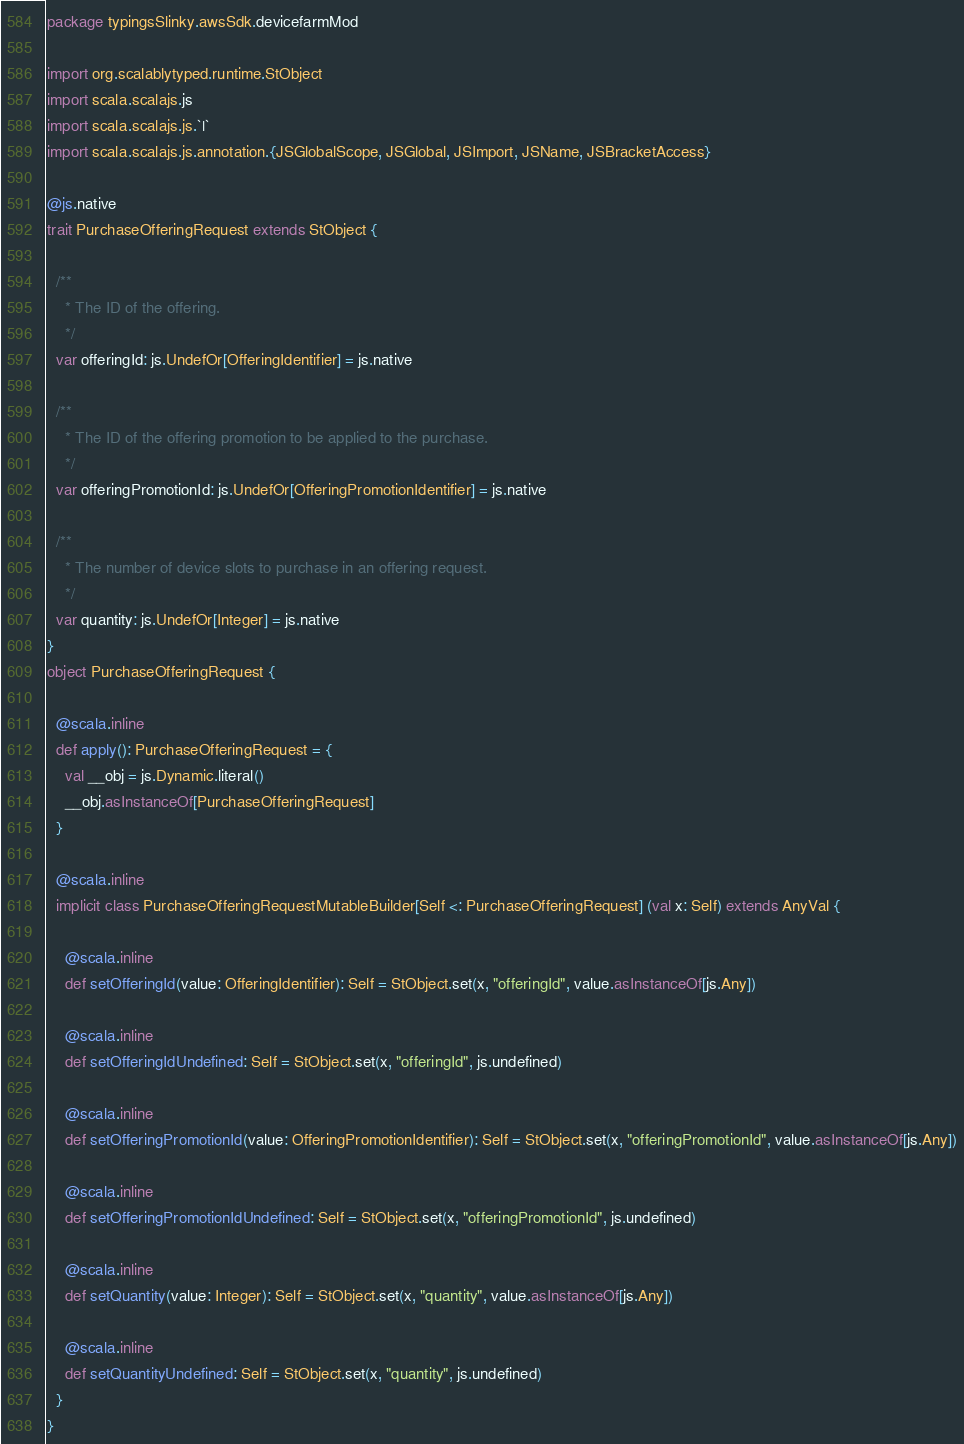Convert code to text. <code><loc_0><loc_0><loc_500><loc_500><_Scala_>package typingsSlinky.awsSdk.devicefarmMod

import org.scalablytyped.runtime.StObject
import scala.scalajs.js
import scala.scalajs.js.`|`
import scala.scalajs.js.annotation.{JSGlobalScope, JSGlobal, JSImport, JSName, JSBracketAccess}

@js.native
trait PurchaseOfferingRequest extends StObject {
  
  /**
    * The ID of the offering.
    */
  var offeringId: js.UndefOr[OfferingIdentifier] = js.native
  
  /**
    * The ID of the offering promotion to be applied to the purchase.
    */
  var offeringPromotionId: js.UndefOr[OfferingPromotionIdentifier] = js.native
  
  /**
    * The number of device slots to purchase in an offering request.
    */
  var quantity: js.UndefOr[Integer] = js.native
}
object PurchaseOfferingRequest {
  
  @scala.inline
  def apply(): PurchaseOfferingRequest = {
    val __obj = js.Dynamic.literal()
    __obj.asInstanceOf[PurchaseOfferingRequest]
  }
  
  @scala.inline
  implicit class PurchaseOfferingRequestMutableBuilder[Self <: PurchaseOfferingRequest] (val x: Self) extends AnyVal {
    
    @scala.inline
    def setOfferingId(value: OfferingIdentifier): Self = StObject.set(x, "offeringId", value.asInstanceOf[js.Any])
    
    @scala.inline
    def setOfferingIdUndefined: Self = StObject.set(x, "offeringId", js.undefined)
    
    @scala.inline
    def setOfferingPromotionId(value: OfferingPromotionIdentifier): Self = StObject.set(x, "offeringPromotionId", value.asInstanceOf[js.Any])
    
    @scala.inline
    def setOfferingPromotionIdUndefined: Self = StObject.set(x, "offeringPromotionId", js.undefined)
    
    @scala.inline
    def setQuantity(value: Integer): Self = StObject.set(x, "quantity", value.asInstanceOf[js.Any])
    
    @scala.inline
    def setQuantityUndefined: Self = StObject.set(x, "quantity", js.undefined)
  }
}
</code> 